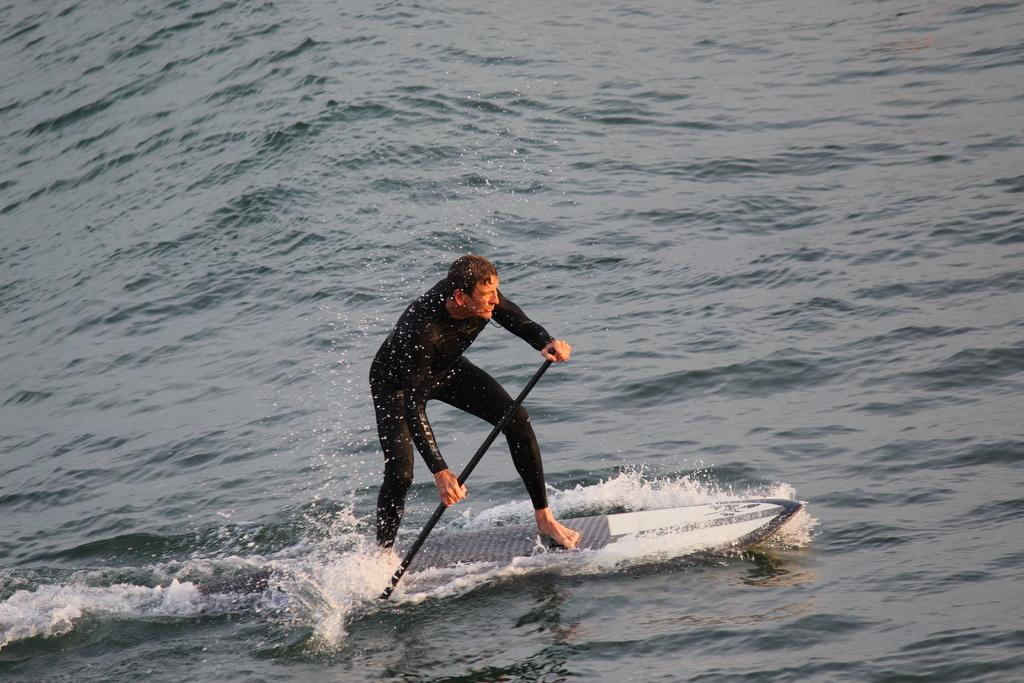Who is the main subject in the image? There is a person in the image. What activity is the person engaged in? The person is surfing. What object is being used for surfing? There is a surfboard in the image. Where is the surfboard located? The surfboard is on the water. What type of soap is being used by the person while surfing in the image? There is no soap present in the image; the person is surfing on a surfboard in the water. 